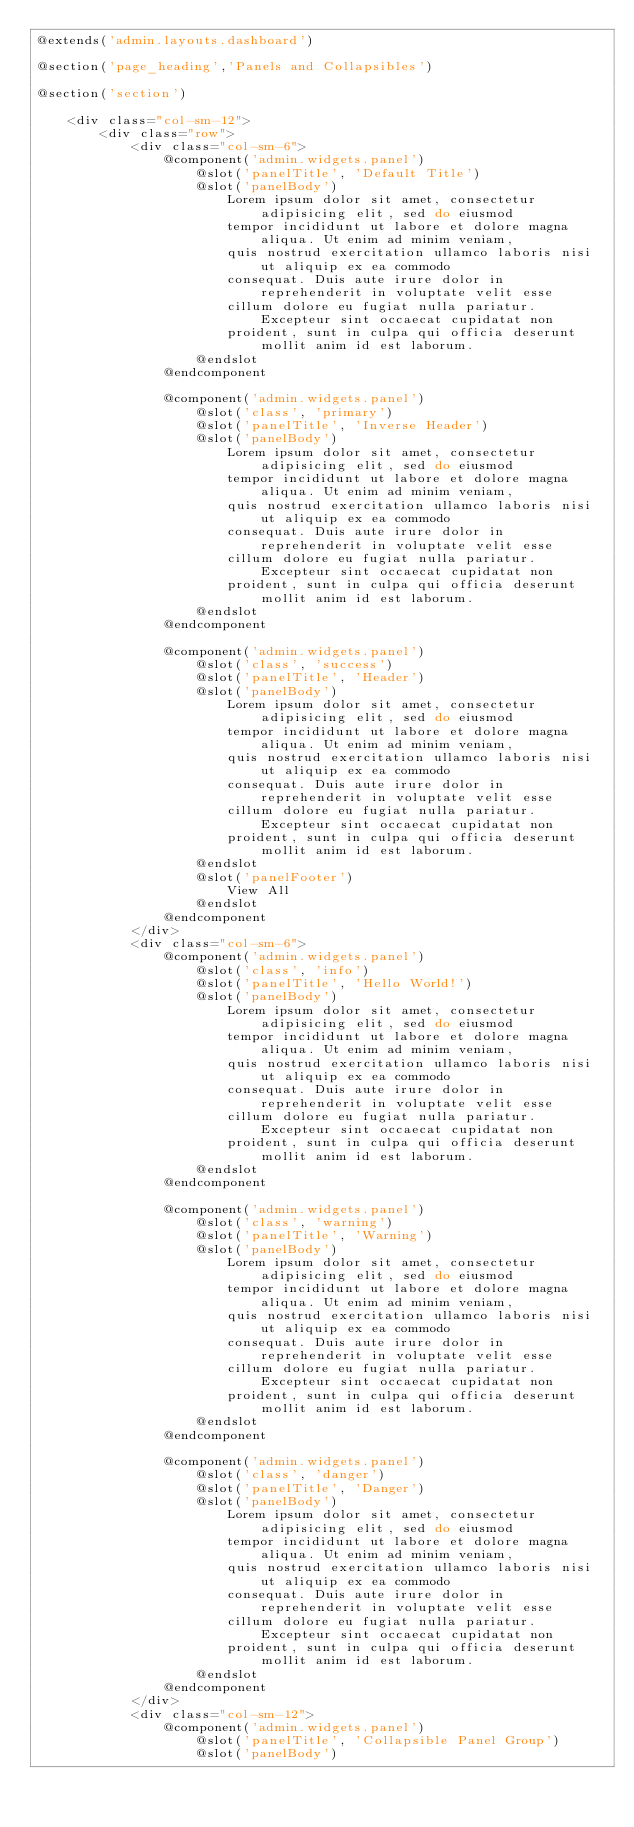Convert code to text. <code><loc_0><loc_0><loc_500><loc_500><_PHP_>@extends('admin.layouts.dashboard')

@section('page_heading','Panels and Collapsibles')

@section('section')

    <div class="col-sm-12">
        <div class="row">
            <div class="col-sm-6">
                @component('admin.widgets.panel')
                    @slot('panelTitle', 'Default Title')
                    @slot('panelBody')
                        Lorem ipsum dolor sit amet, consectetur adipisicing elit, sed do eiusmod
                        tempor incididunt ut labore et dolore magna aliqua. Ut enim ad minim veniam,
                        quis nostrud exercitation ullamco laboris nisi ut aliquip ex ea commodo
                        consequat. Duis aute irure dolor in reprehenderit in voluptate velit esse
                        cillum dolore eu fugiat nulla pariatur. Excepteur sint occaecat cupidatat non
                        proident, sunt in culpa qui officia deserunt mollit anim id est laborum.
                    @endslot
                @endcomponent

                @component('admin.widgets.panel')
                    @slot('class', 'primary')
                    @slot('panelTitle', 'Inverse Header')
                    @slot('panelBody')
                        Lorem ipsum dolor sit amet, consectetur adipisicing elit, sed do eiusmod
                        tempor incididunt ut labore et dolore magna aliqua. Ut enim ad minim veniam,
                        quis nostrud exercitation ullamco laboris nisi ut aliquip ex ea commodo
                        consequat. Duis aute irure dolor in reprehenderit in voluptate velit esse
                        cillum dolore eu fugiat nulla pariatur. Excepteur sint occaecat cupidatat non
                        proident, sunt in culpa qui officia deserunt mollit anim id est laborum.
                    @endslot
                @endcomponent

                @component('admin.widgets.panel')
                    @slot('class', 'success')
                    @slot('panelTitle', 'Header')
                    @slot('panelBody')
                        Lorem ipsum dolor sit amet, consectetur adipisicing elit, sed do eiusmod
                        tempor incididunt ut labore et dolore magna aliqua. Ut enim ad minim veniam,
                        quis nostrud exercitation ullamco laboris nisi ut aliquip ex ea commodo
                        consequat. Duis aute irure dolor in reprehenderit in voluptate velit esse
                        cillum dolore eu fugiat nulla pariatur. Excepteur sint occaecat cupidatat non
                        proident, sunt in culpa qui officia deserunt mollit anim id est laborum.
                    @endslot
                    @slot('panelFooter')
                        View All
                    @endslot
                @endcomponent
            </div>
            <div class="col-sm-6">
                @component('admin.widgets.panel')
                    @slot('class', 'info')
                    @slot('panelTitle', 'Hello World!')
                    @slot('panelBody')
                        Lorem ipsum dolor sit amet, consectetur adipisicing elit, sed do eiusmod
                        tempor incididunt ut labore et dolore magna aliqua. Ut enim ad minim veniam,
                        quis nostrud exercitation ullamco laboris nisi ut aliquip ex ea commodo
                        consequat. Duis aute irure dolor in reprehenderit in voluptate velit esse
                        cillum dolore eu fugiat nulla pariatur. Excepteur sint occaecat cupidatat non
                        proident, sunt in culpa qui officia deserunt mollit anim id est laborum.
                    @endslot
                @endcomponent

                @component('admin.widgets.panel')
                    @slot('class', 'warning')
                    @slot('panelTitle', 'Warning')
                    @slot('panelBody')
                        Lorem ipsum dolor sit amet, consectetur adipisicing elit, sed do eiusmod
                        tempor incididunt ut labore et dolore magna aliqua. Ut enim ad minim veniam,
                        quis nostrud exercitation ullamco laboris nisi ut aliquip ex ea commodo
                        consequat. Duis aute irure dolor in reprehenderit in voluptate velit esse
                        cillum dolore eu fugiat nulla pariatur. Excepteur sint occaecat cupidatat non
                        proident, sunt in culpa qui officia deserunt mollit anim id est laborum.
                    @endslot
                @endcomponent

                @component('admin.widgets.panel')
                    @slot('class', 'danger')
                    @slot('panelTitle', 'Danger')
                    @slot('panelBody')
                        Lorem ipsum dolor sit amet, consectetur adipisicing elit, sed do eiusmod
                        tempor incididunt ut labore et dolore magna aliqua. Ut enim ad minim veniam,
                        quis nostrud exercitation ullamco laboris nisi ut aliquip ex ea commodo
                        consequat. Duis aute irure dolor in reprehenderit in voluptate velit esse
                        cillum dolore eu fugiat nulla pariatur. Excepteur sint occaecat cupidatat non
                        proident, sunt in culpa qui officia deserunt mollit anim id est laborum.
                    @endslot
                @endcomponent
            </div>
            <div class="col-sm-12">
                @component('admin.widgets.panel')
                    @slot('panelTitle', 'Collapsible Panel Group')
                    @slot('panelBody')</code> 